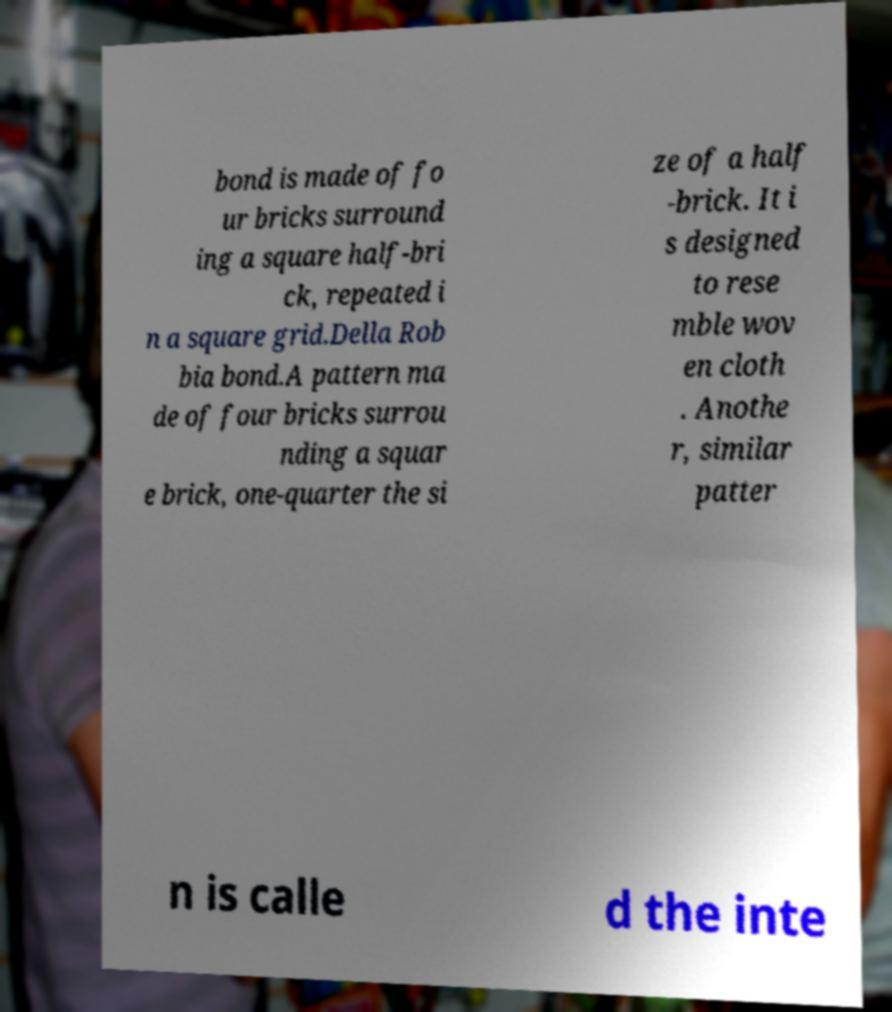Can you read and provide the text displayed in the image?This photo seems to have some interesting text. Can you extract and type it out for me? bond is made of fo ur bricks surround ing a square half-bri ck, repeated i n a square grid.Della Rob bia bond.A pattern ma de of four bricks surrou nding a squar e brick, one-quarter the si ze of a half -brick. It i s designed to rese mble wov en cloth . Anothe r, similar patter n is calle d the inte 